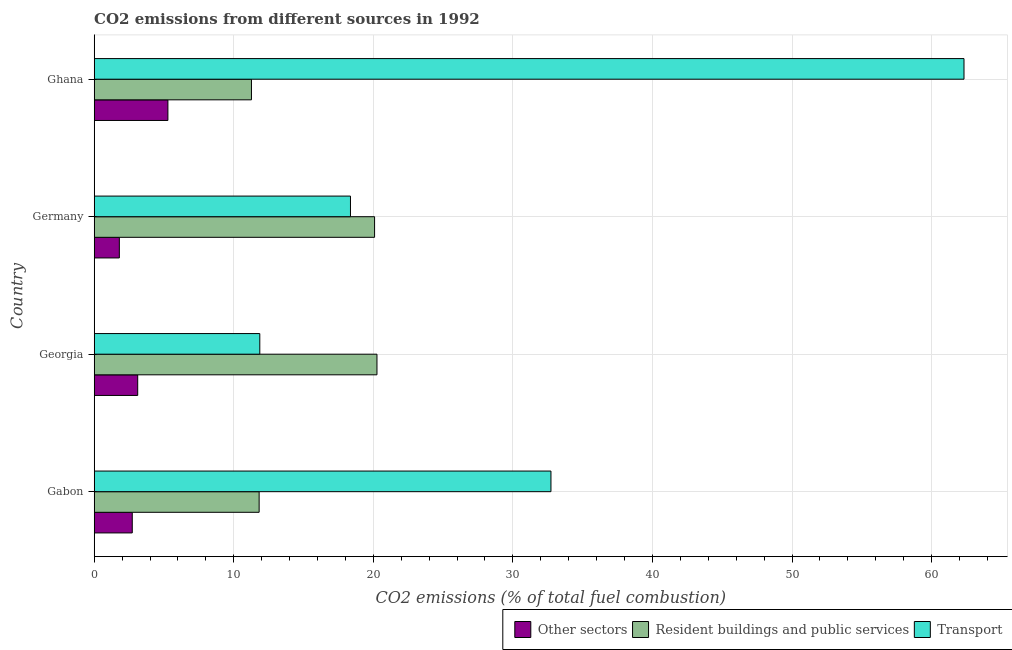Are the number of bars on each tick of the Y-axis equal?
Offer a terse response. Yes. How many bars are there on the 1st tick from the top?
Provide a succinct answer. 3. What is the label of the 4th group of bars from the top?
Keep it short and to the point. Gabon. In how many cases, is the number of bars for a given country not equal to the number of legend labels?
Offer a very short reply. 0. What is the percentage of co2 emissions from other sectors in Ghana?
Offer a terse response. 5.28. Across all countries, what is the maximum percentage of co2 emissions from transport?
Give a very brief answer. 62.32. Across all countries, what is the minimum percentage of co2 emissions from transport?
Ensure brevity in your answer.  11.87. In which country was the percentage of co2 emissions from transport maximum?
Provide a succinct answer. Ghana. In which country was the percentage of co2 emissions from transport minimum?
Offer a very short reply. Georgia. What is the total percentage of co2 emissions from transport in the graph?
Keep it short and to the point. 125.28. What is the difference between the percentage of co2 emissions from other sectors in Germany and that in Ghana?
Your answer should be compact. -3.48. What is the difference between the percentage of co2 emissions from transport in Ghana and the percentage of co2 emissions from other sectors in Germany?
Keep it short and to the point. 60.52. What is the average percentage of co2 emissions from transport per country?
Keep it short and to the point. 31.32. What is the difference between the percentage of co2 emissions from transport and percentage of co2 emissions from resident buildings and public services in Ghana?
Provide a short and direct response. 51.06. In how many countries, is the percentage of co2 emissions from transport greater than 8 %?
Offer a very short reply. 4. What is the ratio of the percentage of co2 emissions from transport in Germany to that in Ghana?
Make the answer very short. 0.29. Is the percentage of co2 emissions from other sectors in Gabon less than that in Germany?
Your answer should be compact. No. Is the difference between the percentage of co2 emissions from resident buildings and public services in Germany and Ghana greater than the difference between the percentage of co2 emissions from other sectors in Germany and Ghana?
Make the answer very short. Yes. What is the difference between the highest and the second highest percentage of co2 emissions from resident buildings and public services?
Provide a short and direct response. 0.17. What is the difference between the highest and the lowest percentage of co2 emissions from other sectors?
Offer a very short reply. 3.48. What does the 2nd bar from the top in Germany represents?
Your answer should be compact. Resident buildings and public services. What does the 1st bar from the bottom in Georgia represents?
Give a very brief answer. Other sectors. How many bars are there?
Make the answer very short. 12. Are all the bars in the graph horizontal?
Offer a terse response. Yes. How many countries are there in the graph?
Ensure brevity in your answer.  4. What is the difference between two consecutive major ticks on the X-axis?
Ensure brevity in your answer.  10. Are the values on the major ticks of X-axis written in scientific E-notation?
Ensure brevity in your answer.  No. Does the graph contain any zero values?
Provide a succinct answer. No. Does the graph contain grids?
Provide a succinct answer. Yes. Where does the legend appear in the graph?
Make the answer very short. Bottom right. How are the legend labels stacked?
Offer a terse response. Horizontal. What is the title of the graph?
Give a very brief answer. CO2 emissions from different sources in 1992. What is the label or title of the X-axis?
Offer a very short reply. CO2 emissions (% of total fuel combustion). What is the CO2 emissions (% of total fuel combustion) in Other sectors in Gabon?
Your response must be concise. 2.73. What is the CO2 emissions (% of total fuel combustion) in Resident buildings and public services in Gabon?
Offer a very short reply. 11.82. What is the CO2 emissions (% of total fuel combustion) of Transport in Gabon?
Your answer should be very brief. 32.73. What is the CO2 emissions (% of total fuel combustion) in Other sectors in Georgia?
Your response must be concise. 3.12. What is the CO2 emissions (% of total fuel combustion) of Resident buildings and public services in Georgia?
Provide a succinct answer. 20.26. What is the CO2 emissions (% of total fuel combustion) of Transport in Georgia?
Give a very brief answer. 11.87. What is the CO2 emissions (% of total fuel combustion) of Other sectors in Germany?
Provide a succinct answer. 1.8. What is the CO2 emissions (% of total fuel combustion) in Resident buildings and public services in Germany?
Ensure brevity in your answer.  20.09. What is the CO2 emissions (% of total fuel combustion) of Transport in Germany?
Your answer should be very brief. 18.36. What is the CO2 emissions (% of total fuel combustion) of Other sectors in Ghana?
Keep it short and to the point. 5.28. What is the CO2 emissions (% of total fuel combustion) of Resident buildings and public services in Ghana?
Give a very brief answer. 11.27. What is the CO2 emissions (% of total fuel combustion) of Transport in Ghana?
Make the answer very short. 62.32. Across all countries, what is the maximum CO2 emissions (% of total fuel combustion) of Other sectors?
Your answer should be compact. 5.28. Across all countries, what is the maximum CO2 emissions (% of total fuel combustion) of Resident buildings and public services?
Provide a short and direct response. 20.26. Across all countries, what is the maximum CO2 emissions (% of total fuel combustion) of Transport?
Make the answer very short. 62.32. Across all countries, what is the minimum CO2 emissions (% of total fuel combustion) of Other sectors?
Give a very brief answer. 1.8. Across all countries, what is the minimum CO2 emissions (% of total fuel combustion) in Resident buildings and public services?
Provide a succinct answer. 11.27. Across all countries, what is the minimum CO2 emissions (% of total fuel combustion) of Transport?
Give a very brief answer. 11.87. What is the total CO2 emissions (% of total fuel combustion) in Other sectors in the graph?
Offer a terse response. 12.93. What is the total CO2 emissions (% of total fuel combustion) of Resident buildings and public services in the graph?
Your response must be concise. 63.44. What is the total CO2 emissions (% of total fuel combustion) in Transport in the graph?
Keep it short and to the point. 125.28. What is the difference between the CO2 emissions (% of total fuel combustion) in Other sectors in Gabon and that in Georgia?
Your answer should be very brief. -0.39. What is the difference between the CO2 emissions (% of total fuel combustion) in Resident buildings and public services in Gabon and that in Georgia?
Keep it short and to the point. -8.44. What is the difference between the CO2 emissions (% of total fuel combustion) of Transport in Gabon and that in Georgia?
Ensure brevity in your answer.  20.86. What is the difference between the CO2 emissions (% of total fuel combustion) in Other sectors in Gabon and that in Germany?
Give a very brief answer. 0.93. What is the difference between the CO2 emissions (% of total fuel combustion) in Resident buildings and public services in Gabon and that in Germany?
Your response must be concise. -8.27. What is the difference between the CO2 emissions (% of total fuel combustion) of Transport in Gabon and that in Germany?
Make the answer very short. 14.36. What is the difference between the CO2 emissions (% of total fuel combustion) in Other sectors in Gabon and that in Ghana?
Ensure brevity in your answer.  -2.55. What is the difference between the CO2 emissions (% of total fuel combustion) of Resident buildings and public services in Gabon and that in Ghana?
Provide a succinct answer. 0.55. What is the difference between the CO2 emissions (% of total fuel combustion) in Transport in Gabon and that in Ghana?
Offer a terse response. -29.6. What is the difference between the CO2 emissions (% of total fuel combustion) in Other sectors in Georgia and that in Germany?
Your answer should be compact. 1.32. What is the difference between the CO2 emissions (% of total fuel combustion) in Resident buildings and public services in Georgia and that in Germany?
Ensure brevity in your answer.  0.17. What is the difference between the CO2 emissions (% of total fuel combustion) in Transport in Georgia and that in Germany?
Provide a short and direct response. -6.5. What is the difference between the CO2 emissions (% of total fuel combustion) in Other sectors in Georgia and that in Ghana?
Your answer should be very brief. -2.16. What is the difference between the CO2 emissions (% of total fuel combustion) of Resident buildings and public services in Georgia and that in Ghana?
Your answer should be compact. 8.99. What is the difference between the CO2 emissions (% of total fuel combustion) of Transport in Georgia and that in Ghana?
Your answer should be very brief. -50.46. What is the difference between the CO2 emissions (% of total fuel combustion) in Other sectors in Germany and that in Ghana?
Your answer should be compact. -3.48. What is the difference between the CO2 emissions (% of total fuel combustion) in Resident buildings and public services in Germany and that in Ghana?
Make the answer very short. 8.82. What is the difference between the CO2 emissions (% of total fuel combustion) of Transport in Germany and that in Ghana?
Make the answer very short. -43.96. What is the difference between the CO2 emissions (% of total fuel combustion) in Other sectors in Gabon and the CO2 emissions (% of total fuel combustion) in Resident buildings and public services in Georgia?
Offer a terse response. -17.53. What is the difference between the CO2 emissions (% of total fuel combustion) in Other sectors in Gabon and the CO2 emissions (% of total fuel combustion) in Transport in Georgia?
Offer a terse response. -9.14. What is the difference between the CO2 emissions (% of total fuel combustion) in Resident buildings and public services in Gabon and the CO2 emissions (% of total fuel combustion) in Transport in Georgia?
Keep it short and to the point. -0.05. What is the difference between the CO2 emissions (% of total fuel combustion) of Other sectors in Gabon and the CO2 emissions (% of total fuel combustion) of Resident buildings and public services in Germany?
Give a very brief answer. -17.36. What is the difference between the CO2 emissions (% of total fuel combustion) of Other sectors in Gabon and the CO2 emissions (% of total fuel combustion) of Transport in Germany?
Ensure brevity in your answer.  -15.64. What is the difference between the CO2 emissions (% of total fuel combustion) of Resident buildings and public services in Gabon and the CO2 emissions (% of total fuel combustion) of Transport in Germany?
Ensure brevity in your answer.  -6.54. What is the difference between the CO2 emissions (% of total fuel combustion) in Other sectors in Gabon and the CO2 emissions (% of total fuel combustion) in Resident buildings and public services in Ghana?
Make the answer very short. -8.54. What is the difference between the CO2 emissions (% of total fuel combustion) in Other sectors in Gabon and the CO2 emissions (% of total fuel combustion) in Transport in Ghana?
Offer a terse response. -59.6. What is the difference between the CO2 emissions (% of total fuel combustion) of Resident buildings and public services in Gabon and the CO2 emissions (% of total fuel combustion) of Transport in Ghana?
Keep it short and to the point. -50.51. What is the difference between the CO2 emissions (% of total fuel combustion) of Other sectors in Georgia and the CO2 emissions (% of total fuel combustion) of Resident buildings and public services in Germany?
Ensure brevity in your answer.  -16.97. What is the difference between the CO2 emissions (% of total fuel combustion) of Other sectors in Georgia and the CO2 emissions (% of total fuel combustion) of Transport in Germany?
Provide a succinct answer. -15.25. What is the difference between the CO2 emissions (% of total fuel combustion) of Resident buildings and public services in Georgia and the CO2 emissions (% of total fuel combustion) of Transport in Germany?
Your response must be concise. 1.9. What is the difference between the CO2 emissions (% of total fuel combustion) of Other sectors in Georgia and the CO2 emissions (% of total fuel combustion) of Resident buildings and public services in Ghana?
Ensure brevity in your answer.  -8.15. What is the difference between the CO2 emissions (% of total fuel combustion) of Other sectors in Georgia and the CO2 emissions (% of total fuel combustion) of Transport in Ghana?
Your response must be concise. -59.21. What is the difference between the CO2 emissions (% of total fuel combustion) of Resident buildings and public services in Georgia and the CO2 emissions (% of total fuel combustion) of Transport in Ghana?
Ensure brevity in your answer.  -42.06. What is the difference between the CO2 emissions (% of total fuel combustion) in Other sectors in Germany and the CO2 emissions (% of total fuel combustion) in Resident buildings and public services in Ghana?
Offer a terse response. -9.47. What is the difference between the CO2 emissions (% of total fuel combustion) of Other sectors in Germany and the CO2 emissions (% of total fuel combustion) of Transport in Ghana?
Make the answer very short. -60.52. What is the difference between the CO2 emissions (% of total fuel combustion) of Resident buildings and public services in Germany and the CO2 emissions (% of total fuel combustion) of Transport in Ghana?
Keep it short and to the point. -42.23. What is the average CO2 emissions (% of total fuel combustion) of Other sectors per country?
Provide a succinct answer. 3.23. What is the average CO2 emissions (% of total fuel combustion) of Resident buildings and public services per country?
Your answer should be very brief. 15.86. What is the average CO2 emissions (% of total fuel combustion) in Transport per country?
Your answer should be compact. 31.32. What is the difference between the CO2 emissions (% of total fuel combustion) in Other sectors and CO2 emissions (% of total fuel combustion) in Resident buildings and public services in Gabon?
Offer a very short reply. -9.09. What is the difference between the CO2 emissions (% of total fuel combustion) in Resident buildings and public services and CO2 emissions (% of total fuel combustion) in Transport in Gabon?
Keep it short and to the point. -20.91. What is the difference between the CO2 emissions (% of total fuel combustion) of Other sectors and CO2 emissions (% of total fuel combustion) of Resident buildings and public services in Georgia?
Your answer should be very brief. -17.14. What is the difference between the CO2 emissions (% of total fuel combustion) in Other sectors and CO2 emissions (% of total fuel combustion) in Transport in Georgia?
Provide a succinct answer. -8.75. What is the difference between the CO2 emissions (% of total fuel combustion) in Resident buildings and public services and CO2 emissions (% of total fuel combustion) in Transport in Georgia?
Your answer should be compact. 8.4. What is the difference between the CO2 emissions (% of total fuel combustion) in Other sectors and CO2 emissions (% of total fuel combustion) in Resident buildings and public services in Germany?
Provide a short and direct response. -18.29. What is the difference between the CO2 emissions (% of total fuel combustion) of Other sectors and CO2 emissions (% of total fuel combustion) of Transport in Germany?
Give a very brief answer. -16.56. What is the difference between the CO2 emissions (% of total fuel combustion) in Resident buildings and public services and CO2 emissions (% of total fuel combustion) in Transport in Germany?
Your answer should be very brief. 1.73. What is the difference between the CO2 emissions (% of total fuel combustion) in Other sectors and CO2 emissions (% of total fuel combustion) in Resident buildings and public services in Ghana?
Your answer should be compact. -5.99. What is the difference between the CO2 emissions (% of total fuel combustion) in Other sectors and CO2 emissions (% of total fuel combustion) in Transport in Ghana?
Offer a very short reply. -57.04. What is the difference between the CO2 emissions (% of total fuel combustion) of Resident buildings and public services and CO2 emissions (% of total fuel combustion) of Transport in Ghana?
Offer a very short reply. -51.06. What is the ratio of the CO2 emissions (% of total fuel combustion) of Other sectors in Gabon to that in Georgia?
Keep it short and to the point. 0.87. What is the ratio of the CO2 emissions (% of total fuel combustion) in Resident buildings and public services in Gabon to that in Georgia?
Make the answer very short. 0.58. What is the ratio of the CO2 emissions (% of total fuel combustion) of Transport in Gabon to that in Georgia?
Provide a short and direct response. 2.76. What is the ratio of the CO2 emissions (% of total fuel combustion) in Other sectors in Gabon to that in Germany?
Provide a succinct answer. 1.51. What is the ratio of the CO2 emissions (% of total fuel combustion) in Resident buildings and public services in Gabon to that in Germany?
Your answer should be compact. 0.59. What is the ratio of the CO2 emissions (% of total fuel combustion) of Transport in Gabon to that in Germany?
Provide a succinct answer. 1.78. What is the ratio of the CO2 emissions (% of total fuel combustion) of Other sectors in Gabon to that in Ghana?
Ensure brevity in your answer.  0.52. What is the ratio of the CO2 emissions (% of total fuel combustion) of Resident buildings and public services in Gabon to that in Ghana?
Make the answer very short. 1.05. What is the ratio of the CO2 emissions (% of total fuel combustion) in Transport in Gabon to that in Ghana?
Make the answer very short. 0.53. What is the ratio of the CO2 emissions (% of total fuel combustion) of Other sectors in Georgia to that in Germany?
Make the answer very short. 1.73. What is the ratio of the CO2 emissions (% of total fuel combustion) in Resident buildings and public services in Georgia to that in Germany?
Give a very brief answer. 1.01. What is the ratio of the CO2 emissions (% of total fuel combustion) of Transport in Georgia to that in Germany?
Give a very brief answer. 0.65. What is the ratio of the CO2 emissions (% of total fuel combustion) in Other sectors in Georgia to that in Ghana?
Provide a short and direct response. 0.59. What is the ratio of the CO2 emissions (% of total fuel combustion) in Resident buildings and public services in Georgia to that in Ghana?
Keep it short and to the point. 1.8. What is the ratio of the CO2 emissions (% of total fuel combustion) of Transport in Georgia to that in Ghana?
Offer a terse response. 0.19. What is the ratio of the CO2 emissions (% of total fuel combustion) in Other sectors in Germany to that in Ghana?
Provide a short and direct response. 0.34. What is the ratio of the CO2 emissions (% of total fuel combustion) of Resident buildings and public services in Germany to that in Ghana?
Provide a succinct answer. 1.78. What is the ratio of the CO2 emissions (% of total fuel combustion) in Transport in Germany to that in Ghana?
Your answer should be very brief. 0.29. What is the difference between the highest and the second highest CO2 emissions (% of total fuel combustion) of Other sectors?
Keep it short and to the point. 2.16. What is the difference between the highest and the second highest CO2 emissions (% of total fuel combustion) of Resident buildings and public services?
Your answer should be very brief. 0.17. What is the difference between the highest and the second highest CO2 emissions (% of total fuel combustion) of Transport?
Offer a terse response. 29.6. What is the difference between the highest and the lowest CO2 emissions (% of total fuel combustion) in Other sectors?
Your response must be concise. 3.48. What is the difference between the highest and the lowest CO2 emissions (% of total fuel combustion) in Resident buildings and public services?
Offer a terse response. 8.99. What is the difference between the highest and the lowest CO2 emissions (% of total fuel combustion) of Transport?
Your response must be concise. 50.46. 